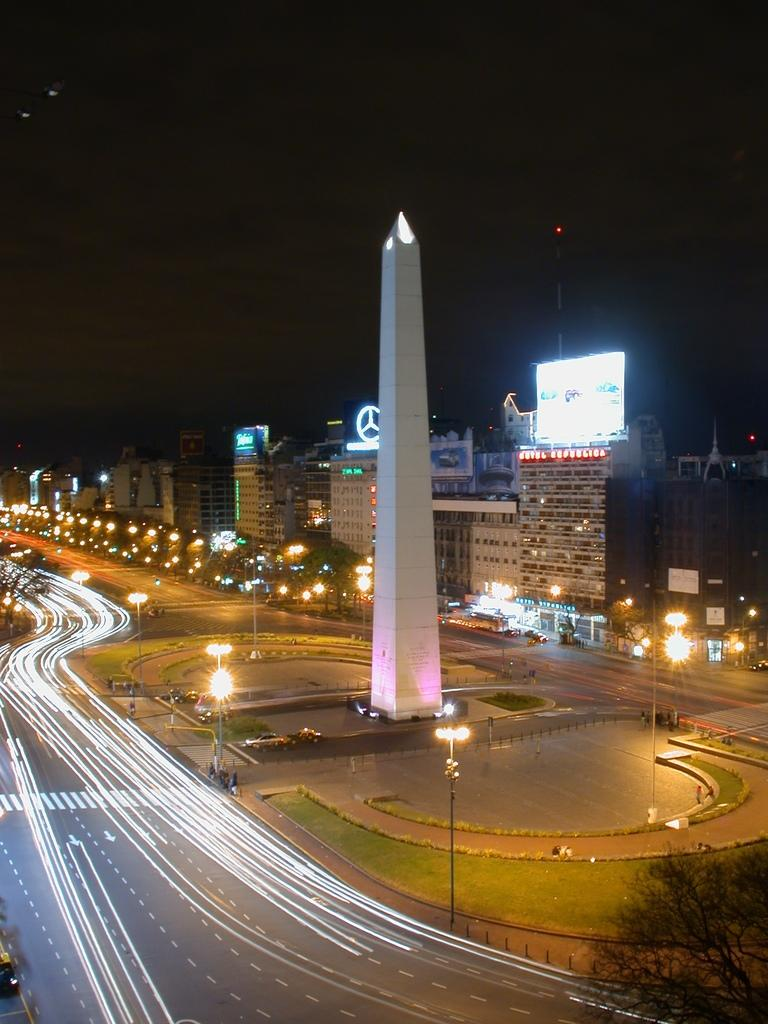What type of structures can be seen in the image? There are buildings and a tower in the image. What electronic devices are present in the image? LED boards are present in the image. What type of street infrastructure is visible in the image? Light poles are visible in the image. What type of vegetation is present in the image? Trees and grass are present in the image. What type of transportation infrastructure is visible in the image? A road is visible in the image. What part of the natural environment is visible in the image? The sky is visible in the image. What type of coat is the tower wearing in the image? There is no coat present in the image, as towers do not wear clothing. 